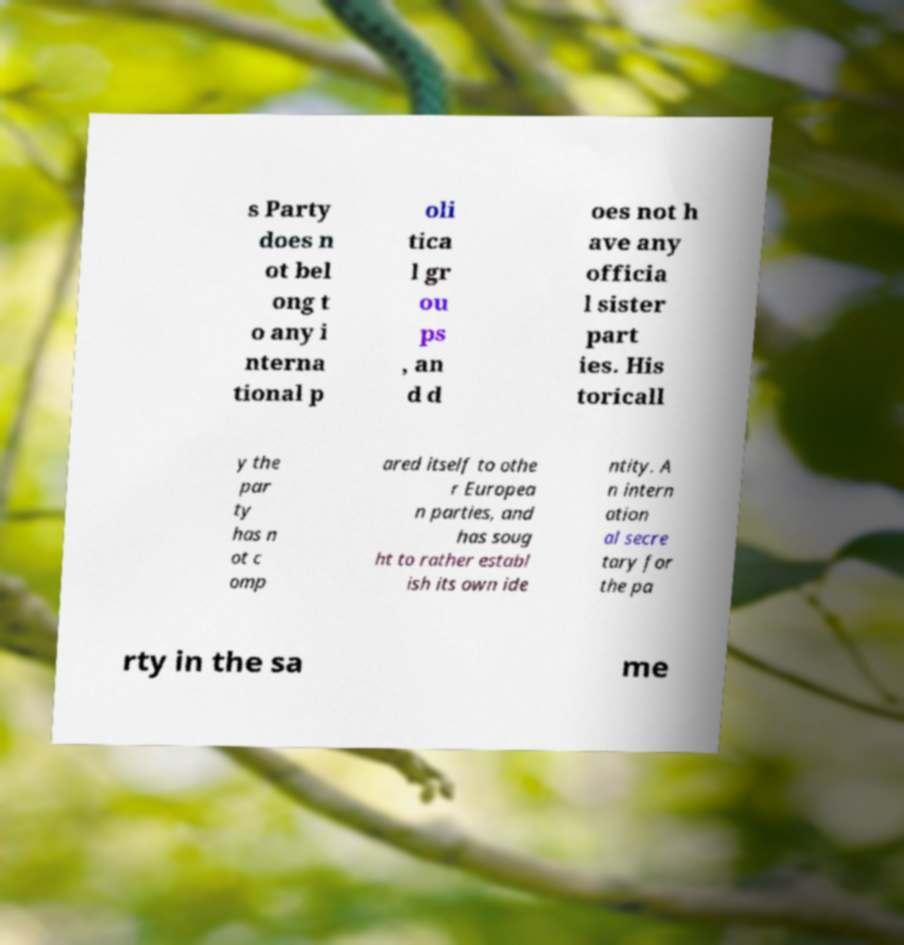Could you assist in decoding the text presented in this image and type it out clearly? s Party does n ot bel ong t o any i nterna tional p oli tica l gr ou ps , an d d oes not h ave any officia l sister part ies. His toricall y the par ty has n ot c omp ared itself to othe r Europea n parties, and has soug ht to rather establ ish its own ide ntity. A n intern ation al secre tary for the pa rty in the sa me 